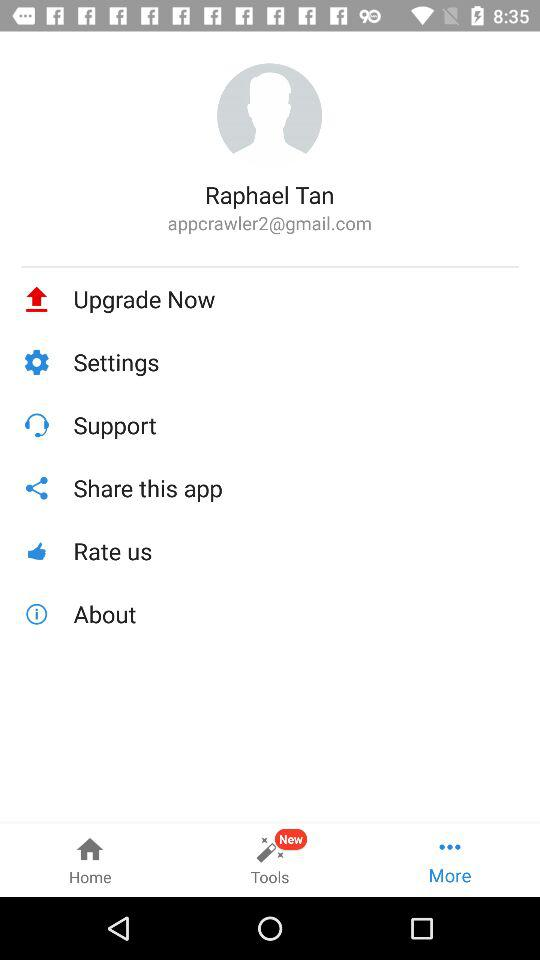What is the email address? The email address is appcrawler2@gmail.com. 